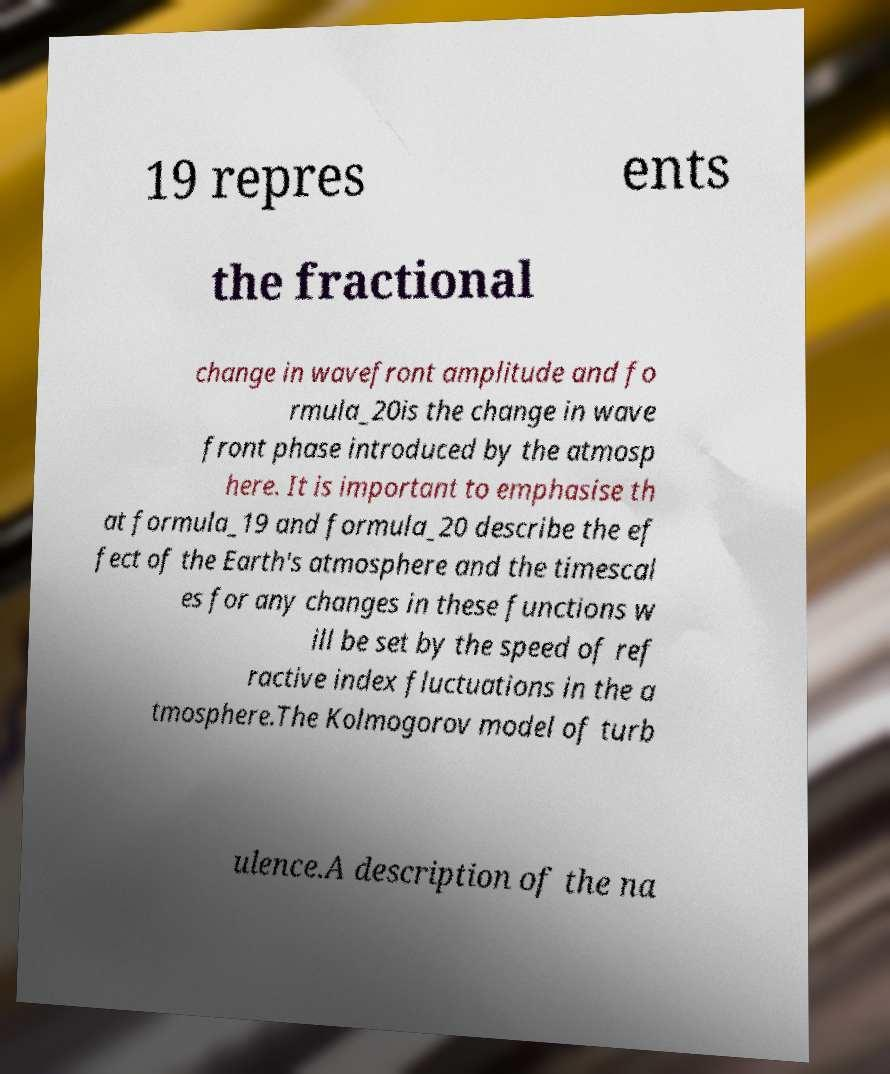Can you accurately transcribe the text from the provided image for me? 19 repres ents the fractional change in wavefront amplitude and fo rmula_20is the change in wave front phase introduced by the atmosp here. It is important to emphasise th at formula_19 and formula_20 describe the ef fect of the Earth's atmosphere and the timescal es for any changes in these functions w ill be set by the speed of ref ractive index fluctuations in the a tmosphere.The Kolmogorov model of turb ulence.A description of the na 